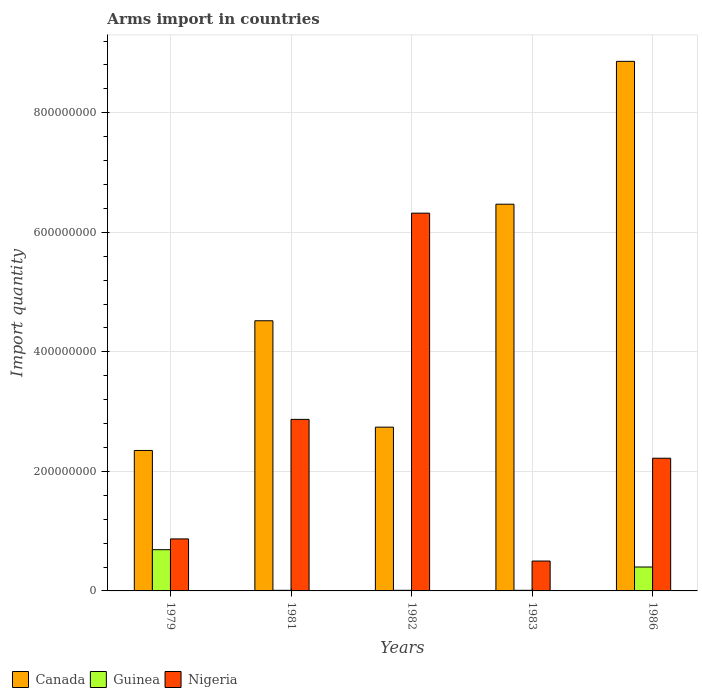How many groups of bars are there?
Offer a terse response. 5. Are the number of bars on each tick of the X-axis equal?
Your answer should be compact. Yes. What is the label of the 2nd group of bars from the left?
Offer a terse response. 1981. In how many cases, is the number of bars for a given year not equal to the number of legend labels?
Your response must be concise. 0. What is the total arms import in Nigeria in 1986?
Your answer should be compact. 2.22e+08. Across all years, what is the maximum total arms import in Guinea?
Your response must be concise. 6.90e+07. In which year was the total arms import in Guinea maximum?
Your response must be concise. 1979. In which year was the total arms import in Guinea minimum?
Your answer should be very brief. 1981. What is the total total arms import in Canada in the graph?
Offer a very short reply. 2.49e+09. What is the difference between the total arms import in Canada in 1981 and that in 1983?
Ensure brevity in your answer.  -1.95e+08. What is the difference between the total arms import in Canada in 1982 and the total arms import in Nigeria in 1979?
Provide a short and direct response. 1.87e+08. What is the average total arms import in Canada per year?
Keep it short and to the point. 4.99e+08. In the year 1986, what is the difference between the total arms import in Guinea and total arms import in Canada?
Ensure brevity in your answer.  -8.46e+08. What is the ratio of the total arms import in Nigeria in 1981 to that in 1986?
Offer a terse response. 1.29. Is the total arms import in Guinea in 1982 less than that in 1983?
Offer a very short reply. No. What is the difference between the highest and the second highest total arms import in Canada?
Your answer should be compact. 2.39e+08. What is the difference between the highest and the lowest total arms import in Canada?
Provide a short and direct response. 6.51e+08. Is the sum of the total arms import in Nigeria in 1979 and 1982 greater than the maximum total arms import in Canada across all years?
Provide a short and direct response. No. What does the 3rd bar from the left in 1982 represents?
Offer a very short reply. Nigeria. What does the 2nd bar from the right in 1982 represents?
Provide a short and direct response. Guinea. How many bars are there?
Ensure brevity in your answer.  15. Where does the legend appear in the graph?
Provide a short and direct response. Bottom left. How are the legend labels stacked?
Make the answer very short. Horizontal. What is the title of the graph?
Your answer should be very brief. Arms import in countries. Does "Burkina Faso" appear as one of the legend labels in the graph?
Give a very brief answer. No. What is the label or title of the X-axis?
Offer a terse response. Years. What is the label or title of the Y-axis?
Provide a succinct answer. Import quantity. What is the Import quantity in Canada in 1979?
Offer a very short reply. 2.35e+08. What is the Import quantity in Guinea in 1979?
Offer a very short reply. 6.90e+07. What is the Import quantity of Nigeria in 1979?
Offer a very short reply. 8.70e+07. What is the Import quantity of Canada in 1981?
Make the answer very short. 4.52e+08. What is the Import quantity in Guinea in 1981?
Offer a very short reply. 1.00e+06. What is the Import quantity in Nigeria in 1981?
Make the answer very short. 2.87e+08. What is the Import quantity in Canada in 1982?
Offer a very short reply. 2.74e+08. What is the Import quantity in Guinea in 1982?
Your answer should be very brief. 1.00e+06. What is the Import quantity of Nigeria in 1982?
Keep it short and to the point. 6.32e+08. What is the Import quantity of Canada in 1983?
Your response must be concise. 6.47e+08. What is the Import quantity of Guinea in 1983?
Your answer should be compact. 1.00e+06. What is the Import quantity in Canada in 1986?
Provide a succinct answer. 8.86e+08. What is the Import quantity in Guinea in 1986?
Keep it short and to the point. 4.00e+07. What is the Import quantity in Nigeria in 1986?
Your answer should be very brief. 2.22e+08. Across all years, what is the maximum Import quantity in Canada?
Provide a succinct answer. 8.86e+08. Across all years, what is the maximum Import quantity in Guinea?
Your response must be concise. 6.90e+07. Across all years, what is the maximum Import quantity of Nigeria?
Make the answer very short. 6.32e+08. Across all years, what is the minimum Import quantity of Canada?
Give a very brief answer. 2.35e+08. Across all years, what is the minimum Import quantity of Guinea?
Offer a very short reply. 1.00e+06. What is the total Import quantity in Canada in the graph?
Give a very brief answer. 2.49e+09. What is the total Import quantity of Guinea in the graph?
Your answer should be very brief. 1.12e+08. What is the total Import quantity of Nigeria in the graph?
Ensure brevity in your answer.  1.28e+09. What is the difference between the Import quantity in Canada in 1979 and that in 1981?
Make the answer very short. -2.17e+08. What is the difference between the Import quantity of Guinea in 1979 and that in 1981?
Make the answer very short. 6.80e+07. What is the difference between the Import quantity in Nigeria in 1979 and that in 1981?
Provide a succinct answer. -2.00e+08. What is the difference between the Import quantity of Canada in 1979 and that in 1982?
Ensure brevity in your answer.  -3.90e+07. What is the difference between the Import quantity of Guinea in 1979 and that in 1982?
Provide a short and direct response. 6.80e+07. What is the difference between the Import quantity in Nigeria in 1979 and that in 1982?
Provide a short and direct response. -5.45e+08. What is the difference between the Import quantity of Canada in 1979 and that in 1983?
Offer a terse response. -4.12e+08. What is the difference between the Import quantity in Guinea in 1979 and that in 1983?
Your response must be concise. 6.80e+07. What is the difference between the Import quantity of Nigeria in 1979 and that in 1983?
Provide a short and direct response. 3.70e+07. What is the difference between the Import quantity in Canada in 1979 and that in 1986?
Provide a short and direct response. -6.51e+08. What is the difference between the Import quantity of Guinea in 1979 and that in 1986?
Your answer should be very brief. 2.90e+07. What is the difference between the Import quantity of Nigeria in 1979 and that in 1986?
Provide a succinct answer. -1.35e+08. What is the difference between the Import quantity in Canada in 1981 and that in 1982?
Keep it short and to the point. 1.78e+08. What is the difference between the Import quantity of Guinea in 1981 and that in 1982?
Provide a succinct answer. 0. What is the difference between the Import quantity in Nigeria in 1981 and that in 1982?
Your response must be concise. -3.45e+08. What is the difference between the Import quantity of Canada in 1981 and that in 1983?
Give a very brief answer. -1.95e+08. What is the difference between the Import quantity of Guinea in 1981 and that in 1983?
Your answer should be very brief. 0. What is the difference between the Import quantity of Nigeria in 1981 and that in 1983?
Ensure brevity in your answer.  2.37e+08. What is the difference between the Import quantity in Canada in 1981 and that in 1986?
Provide a succinct answer. -4.34e+08. What is the difference between the Import quantity in Guinea in 1981 and that in 1986?
Your answer should be very brief. -3.90e+07. What is the difference between the Import quantity in Nigeria in 1981 and that in 1986?
Provide a succinct answer. 6.50e+07. What is the difference between the Import quantity of Canada in 1982 and that in 1983?
Your response must be concise. -3.73e+08. What is the difference between the Import quantity in Guinea in 1982 and that in 1983?
Offer a terse response. 0. What is the difference between the Import quantity in Nigeria in 1982 and that in 1983?
Your answer should be compact. 5.82e+08. What is the difference between the Import quantity of Canada in 1982 and that in 1986?
Offer a terse response. -6.12e+08. What is the difference between the Import quantity in Guinea in 1982 and that in 1986?
Your answer should be compact. -3.90e+07. What is the difference between the Import quantity of Nigeria in 1982 and that in 1986?
Keep it short and to the point. 4.10e+08. What is the difference between the Import quantity of Canada in 1983 and that in 1986?
Ensure brevity in your answer.  -2.39e+08. What is the difference between the Import quantity of Guinea in 1983 and that in 1986?
Ensure brevity in your answer.  -3.90e+07. What is the difference between the Import quantity of Nigeria in 1983 and that in 1986?
Your response must be concise. -1.72e+08. What is the difference between the Import quantity of Canada in 1979 and the Import quantity of Guinea in 1981?
Your response must be concise. 2.34e+08. What is the difference between the Import quantity in Canada in 1979 and the Import quantity in Nigeria in 1981?
Make the answer very short. -5.20e+07. What is the difference between the Import quantity in Guinea in 1979 and the Import quantity in Nigeria in 1981?
Make the answer very short. -2.18e+08. What is the difference between the Import quantity in Canada in 1979 and the Import quantity in Guinea in 1982?
Give a very brief answer. 2.34e+08. What is the difference between the Import quantity in Canada in 1979 and the Import quantity in Nigeria in 1982?
Make the answer very short. -3.97e+08. What is the difference between the Import quantity in Guinea in 1979 and the Import quantity in Nigeria in 1982?
Offer a terse response. -5.63e+08. What is the difference between the Import quantity in Canada in 1979 and the Import quantity in Guinea in 1983?
Keep it short and to the point. 2.34e+08. What is the difference between the Import quantity in Canada in 1979 and the Import quantity in Nigeria in 1983?
Offer a very short reply. 1.85e+08. What is the difference between the Import quantity in Guinea in 1979 and the Import quantity in Nigeria in 1983?
Your response must be concise. 1.90e+07. What is the difference between the Import quantity in Canada in 1979 and the Import quantity in Guinea in 1986?
Your answer should be compact. 1.95e+08. What is the difference between the Import quantity in Canada in 1979 and the Import quantity in Nigeria in 1986?
Offer a terse response. 1.30e+07. What is the difference between the Import quantity of Guinea in 1979 and the Import quantity of Nigeria in 1986?
Your answer should be very brief. -1.53e+08. What is the difference between the Import quantity in Canada in 1981 and the Import quantity in Guinea in 1982?
Offer a terse response. 4.51e+08. What is the difference between the Import quantity in Canada in 1981 and the Import quantity in Nigeria in 1982?
Your answer should be compact. -1.80e+08. What is the difference between the Import quantity of Guinea in 1981 and the Import quantity of Nigeria in 1982?
Make the answer very short. -6.31e+08. What is the difference between the Import quantity in Canada in 1981 and the Import quantity in Guinea in 1983?
Provide a succinct answer. 4.51e+08. What is the difference between the Import quantity in Canada in 1981 and the Import quantity in Nigeria in 1983?
Provide a short and direct response. 4.02e+08. What is the difference between the Import quantity in Guinea in 1981 and the Import quantity in Nigeria in 1983?
Ensure brevity in your answer.  -4.90e+07. What is the difference between the Import quantity in Canada in 1981 and the Import quantity in Guinea in 1986?
Your answer should be very brief. 4.12e+08. What is the difference between the Import quantity in Canada in 1981 and the Import quantity in Nigeria in 1986?
Make the answer very short. 2.30e+08. What is the difference between the Import quantity of Guinea in 1981 and the Import quantity of Nigeria in 1986?
Offer a terse response. -2.21e+08. What is the difference between the Import quantity in Canada in 1982 and the Import quantity in Guinea in 1983?
Ensure brevity in your answer.  2.73e+08. What is the difference between the Import quantity of Canada in 1982 and the Import quantity of Nigeria in 1983?
Keep it short and to the point. 2.24e+08. What is the difference between the Import quantity of Guinea in 1982 and the Import quantity of Nigeria in 1983?
Offer a terse response. -4.90e+07. What is the difference between the Import quantity in Canada in 1982 and the Import quantity in Guinea in 1986?
Provide a short and direct response. 2.34e+08. What is the difference between the Import quantity of Canada in 1982 and the Import quantity of Nigeria in 1986?
Provide a succinct answer. 5.20e+07. What is the difference between the Import quantity of Guinea in 1982 and the Import quantity of Nigeria in 1986?
Provide a short and direct response. -2.21e+08. What is the difference between the Import quantity of Canada in 1983 and the Import quantity of Guinea in 1986?
Provide a succinct answer. 6.07e+08. What is the difference between the Import quantity of Canada in 1983 and the Import quantity of Nigeria in 1986?
Offer a very short reply. 4.25e+08. What is the difference between the Import quantity of Guinea in 1983 and the Import quantity of Nigeria in 1986?
Your answer should be compact. -2.21e+08. What is the average Import quantity of Canada per year?
Make the answer very short. 4.99e+08. What is the average Import quantity of Guinea per year?
Your answer should be compact. 2.24e+07. What is the average Import quantity of Nigeria per year?
Give a very brief answer. 2.56e+08. In the year 1979, what is the difference between the Import quantity of Canada and Import quantity of Guinea?
Your answer should be compact. 1.66e+08. In the year 1979, what is the difference between the Import quantity of Canada and Import quantity of Nigeria?
Your answer should be very brief. 1.48e+08. In the year 1979, what is the difference between the Import quantity of Guinea and Import quantity of Nigeria?
Give a very brief answer. -1.80e+07. In the year 1981, what is the difference between the Import quantity in Canada and Import quantity in Guinea?
Offer a very short reply. 4.51e+08. In the year 1981, what is the difference between the Import quantity of Canada and Import quantity of Nigeria?
Give a very brief answer. 1.65e+08. In the year 1981, what is the difference between the Import quantity of Guinea and Import quantity of Nigeria?
Provide a short and direct response. -2.86e+08. In the year 1982, what is the difference between the Import quantity in Canada and Import quantity in Guinea?
Give a very brief answer. 2.73e+08. In the year 1982, what is the difference between the Import quantity of Canada and Import quantity of Nigeria?
Your answer should be compact. -3.58e+08. In the year 1982, what is the difference between the Import quantity in Guinea and Import quantity in Nigeria?
Offer a very short reply. -6.31e+08. In the year 1983, what is the difference between the Import quantity in Canada and Import quantity in Guinea?
Offer a terse response. 6.46e+08. In the year 1983, what is the difference between the Import quantity of Canada and Import quantity of Nigeria?
Your answer should be compact. 5.97e+08. In the year 1983, what is the difference between the Import quantity in Guinea and Import quantity in Nigeria?
Offer a terse response. -4.90e+07. In the year 1986, what is the difference between the Import quantity of Canada and Import quantity of Guinea?
Offer a very short reply. 8.46e+08. In the year 1986, what is the difference between the Import quantity in Canada and Import quantity in Nigeria?
Make the answer very short. 6.64e+08. In the year 1986, what is the difference between the Import quantity of Guinea and Import quantity of Nigeria?
Make the answer very short. -1.82e+08. What is the ratio of the Import quantity of Canada in 1979 to that in 1981?
Your answer should be very brief. 0.52. What is the ratio of the Import quantity in Guinea in 1979 to that in 1981?
Provide a short and direct response. 69. What is the ratio of the Import quantity of Nigeria in 1979 to that in 1981?
Give a very brief answer. 0.3. What is the ratio of the Import quantity of Canada in 1979 to that in 1982?
Your answer should be compact. 0.86. What is the ratio of the Import quantity of Nigeria in 1979 to that in 1982?
Keep it short and to the point. 0.14. What is the ratio of the Import quantity in Canada in 1979 to that in 1983?
Your response must be concise. 0.36. What is the ratio of the Import quantity of Guinea in 1979 to that in 1983?
Give a very brief answer. 69. What is the ratio of the Import quantity of Nigeria in 1979 to that in 1983?
Your answer should be very brief. 1.74. What is the ratio of the Import quantity in Canada in 1979 to that in 1986?
Offer a very short reply. 0.27. What is the ratio of the Import quantity of Guinea in 1979 to that in 1986?
Your answer should be compact. 1.73. What is the ratio of the Import quantity of Nigeria in 1979 to that in 1986?
Give a very brief answer. 0.39. What is the ratio of the Import quantity of Canada in 1981 to that in 1982?
Offer a terse response. 1.65. What is the ratio of the Import quantity of Guinea in 1981 to that in 1982?
Your answer should be very brief. 1. What is the ratio of the Import quantity of Nigeria in 1981 to that in 1982?
Your answer should be very brief. 0.45. What is the ratio of the Import quantity in Canada in 1981 to that in 1983?
Give a very brief answer. 0.7. What is the ratio of the Import quantity of Nigeria in 1981 to that in 1983?
Keep it short and to the point. 5.74. What is the ratio of the Import quantity in Canada in 1981 to that in 1986?
Provide a succinct answer. 0.51. What is the ratio of the Import quantity in Guinea in 1981 to that in 1986?
Offer a very short reply. 0.03. What is the ratio of the Import quantity of Nigeria in 1981 to that in 1986?
Offer a very short reply. 1.29. What is the ratio of the Import quantity of Canada in 1982 to that in 1983?
Ensure brevity in your answer.  0.42. What is the ratio of the Import quantity in Nigeria in 1982 to that in 1983?
Ensure brevity in your answer.  12.64. What is the ratio of the Import quantity of Canada in 1982 to that in 1986?
Provide a short and direct response. 0.31. What is the ratio of the Import quantity in Guinea in 1982 to that in 1986?
Provide a short and direct response. 0.03. What is the ratio of the Import quantity of Nigeria in 1982 to that in 1986?
Keep it short and to the point. 2.85. What is the ratio of the Import quantity of Canada in 1983 to that in 1986?
Your response must be concise. 0.73. What is the ratio of the Import quantity of Guinea in 1983 to that in 1986?
Your answer should be compact. 0.03. What is the ratio of the Import quantity in Nigeria in 1983 to that in 1986?
Offer a very short reply. 0.23. What is the difference between the highest and the second highest Import quantity in Canada?
Keep it short and to the point. 2.39e+08. What is the difference between the highest and the second highest Import quantity of Guinea?
Make the answer very short. 2.90e+07. What is the difference between the highest and the second highest Import quantity of Nigeria?
Your answer should be very brief. 3.45e+08. What is the difference between the highest and the lowest Import quantity of Canada?
Your answer should be compact. 6.51e+08. What is the difference between the highest and the lowest Import quantity of Guinea?
Offer a terse response. 6.80e+07. What is the difference between the highest and the lowest Import quantity of Nigeria?
Offer a very short reply. 5.82e+08. 